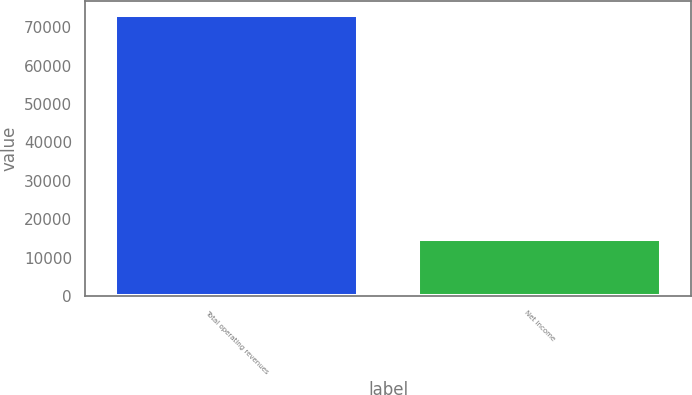Convert chart. <chart><loc_0><loc_0><loc_500><loc_500><bar_chart><fcel>Total operating revenues<fcel>Net income<nl><fcel>73189<fcel>14787<nl></chart> 